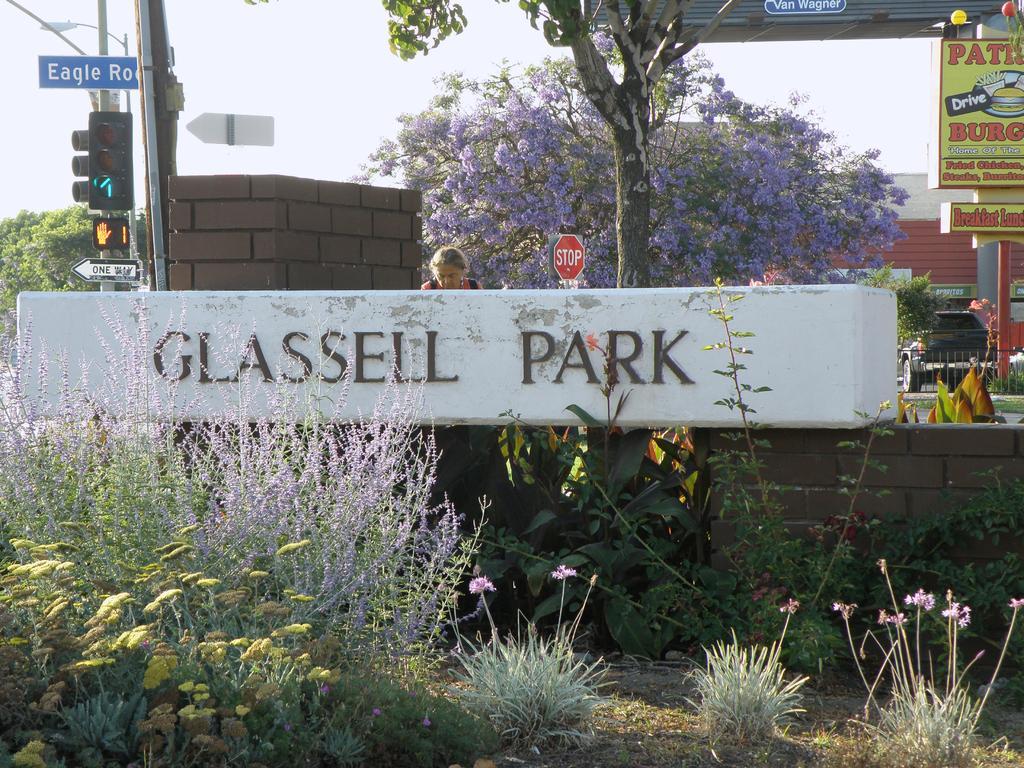Describe this image in one or two sentences. At the bottom of the picture, we see the grass and the plants which have flowers and these flowers are in yellow and violet color. In the middle, we see a board in white color with text written as "GLASSELL PARK". Behind that, we see a wall and a woman is standing. Beside her, we see a traffic board. On the left side, we see the poles, street lights and traffic signal. We see the board in white and blue color. On the right side, we see the railing, pole and a board in yellow color with some text written. Behind that, we see a car is moving on the road. In the background, we see a tree which has violet flowers. In the background, we see a building in white and brown color. At the top, we see the sky. 